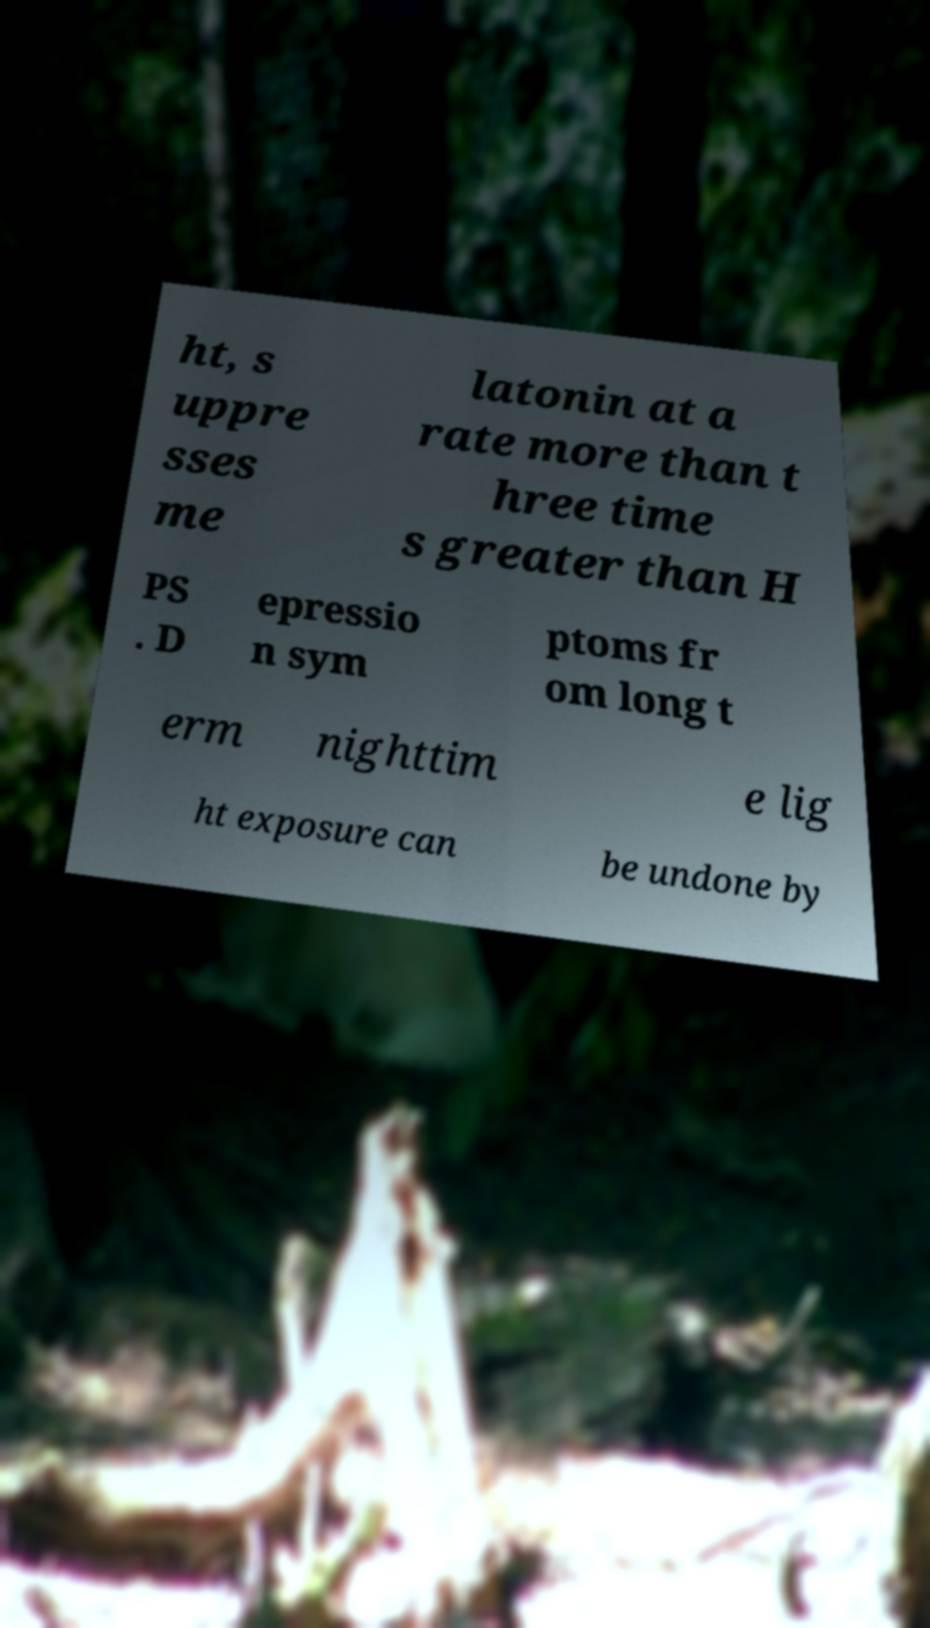I need the written content from this picture converted into text. Can you do that? ht, s uppre sses me latonin at a rate more than t hree time s greater than H PS . D epressio n sym ptoms fr om long t erm nighttim e lig ht exposure can be undone by 